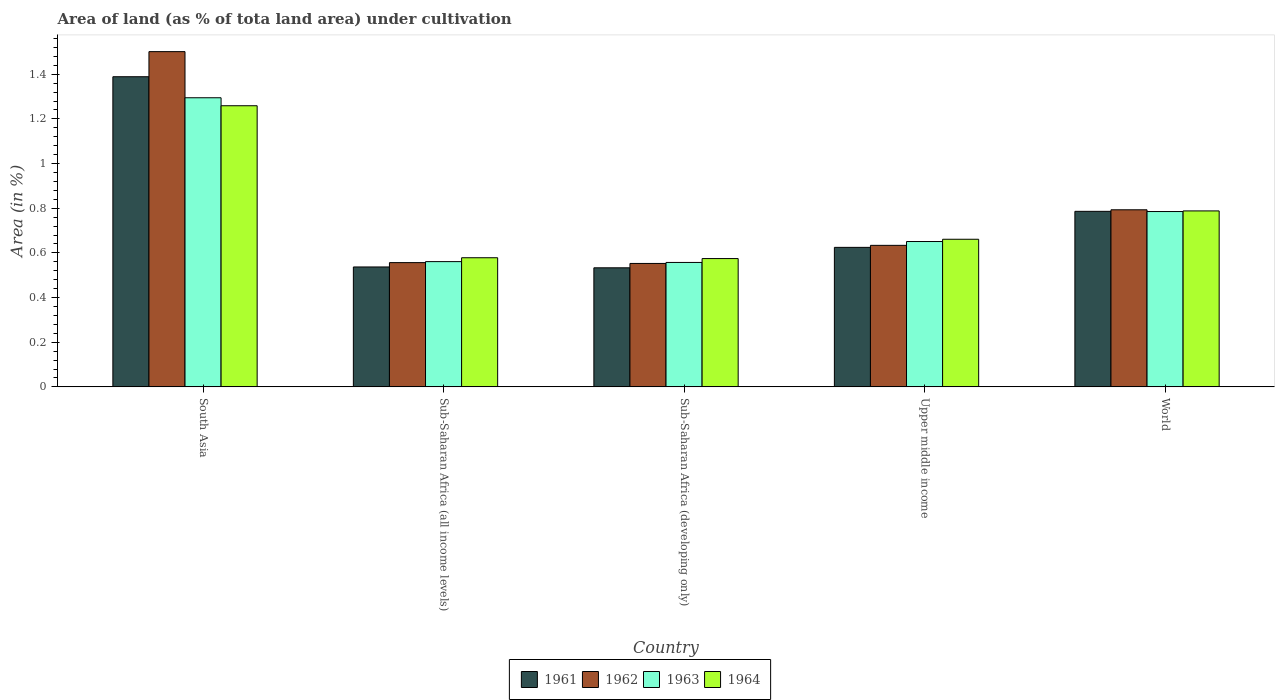How many different coloured bars are there?
Give a very brief answer. 4. Are the number of bars on each tick of the X-axis equal?
Keep it short and to the point. Yes. How many bars are there on the 1st tick from the right?
Your response must be concise. 4. What is the label of the 2nd group of bars from the left?
Make the answer very short. Sub-Saharan Africa (all income levels). What is the percentage of land under cultivation in 1964 in South Asia?
Provide a succinct answer. 1.26. Across all countries, what is the maximum percentage of land under cultivation in 1961?
Give a very brief answer. 1.39. Across all countries, what is the minimum percentage of land under cultivation in 1964?
Provide a succinct answer. 0.57. In which country was the percentage of land under cultivation in 1961 minimum?
Provide a short and direct response. Sub-Saharan Africa (developing only). What is the total percentage of land under cultivation in 1962 in the graph?
Provide a succinct answer. 4.04. What is the difference between the percentage of land under cultivation in 1964 in Sub-Saharan Africa (all income levels) and that in Sub-Saharan Africa (developing only)?
Provide a short and direct response. 0. What is the difference between the percentage of land under cultivation in 1964 in Sub-Saharan Africa (developing only) and the percentage of land under cultivation in 1961 in Sub-Saharan Africa (all income levels)?
Your response must be concise. 0.04. What is the average percentage of land under cultivation in 1962 per country?
Your response must be concise. 0.81. What is the difference between the percentage of land under cultivation of/in 1961 and percentage of land under cultivation of/in 1963 in Sub-Saharan Africa (developing only)?
Your response must be concise. -0.02. What is the ratio of the percentage of land under cultivation in 1964 in Sub-Saharan Africa (all income levels) to that in Sub-Saharan Africa (developing only)?
Offer a very short reply. 1.01. Is the difference between the percentage of land under cultivation in 1961 in Sub-Saharan Africa (developing only) and World greater than the difference between the percentage of land under cultivation in 1963 in Sub-Saharan Africa (developing only) and World?
Keep it short and to the point. No. What is the difference between the highest and the second highest percentage of land under cultivation in 1962?
Your response must be concise. -0.71. What is the difference between the highest and the lowest percentage of land under cultivation in 1963?
Offer a very short reply. 0.74. In how many countries, is the percentage of land under cultivation in 1964 greater than the average percentage of land under cultivation in 1964 taken over all countries?
Provide a short and direct response. 2. Is the sum of the percentage of land under cultivation in 1963 in Sub-Saharan Africa (all income levels) and Upper middle income greater than the maximum percentage of land under cultivation in 1962 across all countries?
Provide a short and direct response. No. Is it the case that in every country, the sum of the percentage of land under cultivation in 1963 and percentage of land under cultivation in 1961 is greater than the sum of percentage of land under cultivation in 1962 and percentage of land under cultivation in 1964?
Keep it short and to the point. No. What does the 4th bar from the left in Sub-Saharan Africa (developing only) represents?
Provide a short and direct response. 1964. What does the 1st bar from the right in Upper middle income represents?
Your answer should be very brief. 1964. Is it the case that in every country, the sum of the percentage of land under cultivation in 1964 and percentage of land under cultivation in 1963 is greater than the percentage of land under cultivation in 1961?
Offer a very short reply. Yes. Are all the bars in the graph horizontal?
Provide a succinct answer. No. How many countries are there in the graph?
Your response must be concise. 5. What is the difference between two consecutive major ticks on the Y-axis?
Provide a succinct answer. 0.2. Are the values on the major ticks of Y-axis written in scientific E-notation?
Keep it short and to the point. No. Does the graph contain grids?
Your answer should be very brief. No. Where does the legend appear in the graph?
Ensure brevity in your answer.  Bottom center. How are the legend labels stacked?
Offer a terse response. Horizontal. What is the title of the graph?
Keep it short and to the point. Area of land (as % of tota land area) under cultivation. Does "2000" appear as one of the legend labels in the graph?
Keep it short and to the point. No. What is the label or title of the X-axis?
Offer a very short reply. Country. What is the label or title of the Y-axis?
Ensure brevity in your answer.  Area (in %). What is the Area (in %) of 1961 in South Asia?
Give a very brief answer. 1.39. What is the Area (in %) of 1962 in South Asia?
Your response must be concise. 1.5. What is the Area (in %) of 1963 in South Asia?
Offer a terse response. 1.29. What is the Area (in %) of 1964 in South Asia?
Ensure brevity in your answer.  1.26. What is the Area (in %) in 1961 in Sub-Saharan Africa (all income levels)?
Make the answer very short. 0.54. What is the Area (in %) in 1962 in Sub-Saharan Africa (all income levels)?
Keep it short and to the point. 0.56. What is the Area (in %) in 1963 in Sub-Saharan Africa (all income levels)?
Provide a succinct answer. 0.56. What is the Area (in %) in 1964 in Sub-Saharan Africa (all income levels)?
Offer a terse response. 0.58. What is the Area (in %) in 1961 in Sub-Saharan Africa (developing only)?
Keep it short and to the point. 0.53. What is the Area (in %) of 1962 in Sub-Saharan Africa (developing only)?
Ensure brevity in your answer.  0.55. What is the Area (in %) of 1963 in Sub-Saharan Africa (developing only)?
Provide a short and direct response. 0.56. What is the Area (in %) in 1964 in Sub-Saharan Africa (developing only)?
Provide a succinct answer. 0.57. What is the Area (in %) in 1961 in Upper middle income?
Provide a succinct answer. 0.62. What is the Area (in %) of 1962 in Upper middle income?
Make the answer very short. 0.63. What is the Area (in %) of 1963 in Upper middle income?
Your response must be concise. 0.65. What is the Area (in %) in 1964 in Upper middle income?
Ensure brevity in your answer.  0.66. What is the Area (in %) in 1961 in World?
Offer a very short reply. 0.79. What is the Area (in %) of 1962 in World?
Your answer should be compact. 0.79. What is the Area (in %) of 1963 in World?
Your response must be concise. 0.79. What is the Area (in %) of 1964 in World?
Your answer should be compact. 0.79. Across all countries, what is the maximum Area (in %) of 1961?
Your answer should be very brief. 1.39. Across all countries, what is the maximum Area (in %) in 1962?
Your response must be concise. 1.5. Across all countries, what is the maximum Area (in %) in 1963?
Provide a succinct answer. 1.29. Across all countries, what is the maximum Area (in %) in 1964?
Offer a terse response. 1.26. Across all countries, what is the minimum Area (in %) of 1961?
Your answer should be very brief. 0.53. Across all countries, what is the minimum Area (in %) in 1962?
Keep it short and to the point. 0.55. Across all countries, what is the minimum Area (in %) of 1963?
Provide a short and direct response. 0.56. Across all countries, what is the minimum Area (in %) of 1964?
Keep it short and to the point. 0.57. What is the total Area (in %) in 1961 in the graph?
Provide a succinct answer. 3.87. What is the total Area (in %) of 1962 in the graph?
Make the answer very short. 4.04. What is the total Area (in %) of 1963 in the graph?
Provide a short and direct response. 3.85. What is the total Area (in %) of 1964 in the graph?
Offer a very short reply. 3.86. What is the difference between the Area (in %) in 1961 in South Asia and that in Sub-Saharan Africa (all income levels)?
Give a very brief answer. 0.85. What is the difference between the Area (in %) in 1962 in South Asia and that in Sub-Saharan Africa (all income levels)?
Keep it short and to the point. 0.94. What is the difference between the Area (in %) of 1963 in South Asia and that in Sub-Saharan Africa (all income levels)?
Ensure brevity in your answer.  0.73. What is the difference between the Area (in %) of 1964 in South Asia and that in Sub-Saharan Africa (all income levels)?
Offer a very short reply. 0.68. What is the difference between the Area (in %) in 1961 in South Asia and that in Sub-Saharan Africa (developing only)?
Ensure brevity in your answer.  0.86. What is the difference between the Area (in %) in 1962 in South Asia and that in Sub-Saharan Africa (developing only)?
Give a very brief answer. 0.95. What is the difference between the Area (in %) of 1963 in South Asia and that in Sub-Saharan Africa (developing only)?
Offer a very short reply. 0.74. What is the difference between the Area (in %) of 1964 in South Asia and that in Sub-Saharan Africa (developing only)?
Provide a succinct answer. 0.68. What is the difference between the Area (in %) of 1961 in South Asia and that in Upper middle income?
Make the answer very short. 0.76. What is the difference between the Area (in %) in 1962 in South Asia and that in Upper middle income?
Make the answer very short. 0.87. What is the difference between the Area (in %) of 1963 in South Asia and that in Upper middle income?
Make the answer very short. 0.64. What is the difference between the Area (in %) of 1964 in South Asia and that in Upper middle income?
Offer a terse response. 0.6. What is the difference between the Area (in %) in 1961 in South Asia and that in World?
Provide a succinct answer. 0.6. What is the difference between the Area (in %) in 1962 in South Asia and that in World?
Ensure brevity in your answer.  0.71. What is the difference between the Area (in %) in 1963 in South Asia and that in World?
Offer a terse response. 0.51. What is the difference between the Area (in %) in 1964 in South Asia and that in World?
Offer a very short reply. 0.47. What is the difference between the Area (in %) in 1961 in Sub-Saharan Africa (all income levels) and that in Sub-Saharan Africa (developing only)?
Make the answer very short. 0. What is the difference between the Area (in %) in 1962 in Sub-Saharan Africa (all income levels) and that in Sub-Saharan Africa (developing only)?
Make the answer very short. 0. What is the difference between the Area (in %) in 1963 in Sub-Saharan Africa (all income levels) and that in Sub-Saharan Africa (developing only)?
Your response must be concise. 0. What is the difference between the Area (in %) of 1964 in Sub-Saharan Africa (all income levels) and that in Sub-Saharan Africa (developing only)?
Provide a short and direct response. 0. What is the difference between the Area (in %) of 1961 in Sub-Saharan Africa (all income levels) and that in Upper middle income?
Ensure brevity in your answer.  -0.09. What is the difference between the Area (in %) of 1962 in Sub-Saharan Africa (all income levels) and that in Upper middle income?
Provide a short and direct response. -0.08. What is the difference between the Area (in %) of 1963 in Sub-Saharan Africa (all income levels) and that in Upper middle income?
Offer a terse response. -0.09. What is the difference between the Area (in %) of 1964 in Sub-Saharan Africa (all income levels) and that in Upper middle income?
Make the answer very short. -0.08. What is the difference between the Area (in %) in 1961 in Sub-Saharan Africa (all income levels) and that in World?
Your answer should be compact. -0.25. What is the difference between the Area (in %) of 1962 in Sub-Saharan Africa (all income levels) and that in World?
Ensure brevity in your answer.  -0.24. What is the difference between the Area (in %) of 1963 in Sub-Saharan Africa (all income levels) and that in World?
Provide a short and direct response. -0.22. What is the difference between the Area (in %) in 1964 in Sub-Saharan Africa (all income levels) and that in World?
Provide a succinct answer. -0.21. What is the difference between the Area (in %) in 1961 in Sub-Saharan Africa (developing only) and that in Upper middle income?
Offer a very short reply. -0.09. What is the difference between the Area (in %) of 1962 in Sub-Saharan Africa (developing only) and that in Upper middle income?
Provide a succinct answer. -0.08. What is the difference between the Area (in %) of 1963 in Sub-Saharan Africa (developing only) and that in Upper middle income?
Offer a very short reply. -0.09. What is the difference between the Area (in %) in 1964 in Sub-Saharan Africa (developing only) and that in Upper middle income?
Make the answer very short. -0.09. What is the difference between the Area (in %) in 1961 in Sub-Saharan Africa (developing only) and that in World?
Your answer should be compact. -0.25. What is the difference between the Area (in %) of 1962 in Sub-Saharan Africa (developing only) and that in World?
Offer a very short reply. -0.24. What is the difference between the Area (in %) of 1963 in Sub-Saharan Africa (developing only) and that in World?
Your answer should be very brief. -0.23. What is the difference between the Area (in %) in 1964 in Sub-Saharan Africa (developing only) and that in World?
Your response must be concise. -0.21. What is the difference between the Area (in %) in 1961 in Upper middle income and that in World?
Offer a very short reply. -0.16. What is the difference between the Area (in %) of 1962 in Upper middle income and that in World?
Keep it short and to the point. -0.16. What is the difference between the Area (in %) in 1963 in Upper middle income and that in World?
Ensure brevity in your answer.  -0.13. What is the difference between the Area (in %) in 1964 in Upper middle income and that in World?
Give a very brief answer. -0.13. What is the difference between the Area (in %) of 1961 in South Asia and the Area (in %) of 1962 in Sub-Saharan Africa (all income levels)?
Your answer should be compact. 0.83. What is the difference between the Area (in %) of 1961 in South Asia and the Area (in %) of 1963 in Sub-Saharan Africa (all income levels)?
Your answer should be compact. 0.83. What is the difference between the Area (in %) of 1961 in South Asia and the Area (in %) of 1964 in Sub-Saharan Africa (all income levels)?
Your response must be concise. 0.81. What is the difference between the Area (in %) of 1962 in South Asia and the Area (in %) of 1963 in Sub-Saharan Africa (all income levels)?
Your answer should be very brief. 0.94. What is the difference between the Area (in %) in 1962 in South Asia and the Area (in %) in 1964 in Sub-Saharan Africa (all income levels)?
Your response must be concise. 0.92. What is the difference between the Area (in %) in 1963 in South Asia and the Area (in %) in 1964 in Sub-Saharan Africa (all income levels)?
Your answer should be very brief. 0.72. What is the difference between the Area (in %) in 1961 in South Asia and the Area (in %) in 1962 in Sub-Saharan Africa (developing only)?
Offer a very short reply. 0.84. What is the difference between the Area (in %) of 1961 in South Asia and the Area (in %) of 1963 in Sub-Saharan Africa (developing only)?
Your answer should be compact. 0.83. What is the difference between the Area (in %) in 1961 in South Asia and the Area (in %) in 1964 in Sub-Saharan Africa (developing only)?
Provide a succinct answer. 0.81. What is the difference between the Area (in %) in 1962 in South Asia and the Area (in %) in 1963 in Sub-Saharan Africa (developing only)?
Give a very brief answer. 0.94. What is the difference between the Area (in %) in 1962 in South Asia and the Area (in %) in 1964 in Sub-Saharan Africa (developing only)?
Your answer should be very brief. 0.93. What is the difference between the Area (in %) of 1963 in South Asia and the Area (in %) of 1964 in Sub-Saharan Africa (developing only)?
Your answer should be very brief. 0.72. What is the difference between the Area (in %) of 1961 in South Asia and the Area (in %) of 1962 in Upper middle income?
Your answer should be very brief. 0.76. What is the difference between the Area (in %) of 1961 in South Asia and the Area (in %) of 1963 in Upper middle income?
Keep it short and to the point. 0.74. What is the difference between the Area (in %) in 1961 in South Asia and the Area (in %) in 1964 in Upper middle income?
Provide a succinct answer. 0.73. What is the difference between the Area (in %) in 1962 in South Asia and the Area (in %) in 1963 in Upper middle income?
Ensure brevity in your answer.  0.85. What is the difference between the Area (in %) in 1962 in South Asia and the Area (in %) in 1964 in Upper middle income?
Your answer should be very brief. 0.84. What is the difference between the Area (in %) of 1963 in South Asia and the Area (in %) of 1964 in Upper middle income?
Your response must be concise. 0.63. What is the difference between the Area (in %) in 1961 in South Asia and the Area (in %) in 1962 in World?
Your response must be concise. 0.6. What is the difference between the Area (in %) in 1961 in South Asia and the Area (in %) in 1963 in World?
Keep it short and to the point. 0.6. What is the difference between the Area (in %) in 1961 in South Asia and the Area (in %) in 1964 in World?
Your answer should be compact. 0.6. What is the difference between the Area (in %) of 1962 in South Asia and the Area (in %) of 1963 in World?
Offer a terse response. 0.72. What is the difference between the Area (in %) in 1962 in South Asia and the Area (in %) in 1964 in World?
Make the answer very short. 0.71. What is the difference between the Area (in %) in 1963 in South Asia and the Area (in %) in 1964 in World?
Offer a terse response. 0.51. What is the difference between the Area (in %) of 1961 in Sub-Saharan Africa (all income levels) and the Area (in %) of 1962 in Sub-Saharan Africa (developing only)?
Your response must be concise. -0.02. What is the difference between the Area (in %) of 1961 in Sub-Saharan Africa (all income levels) and the Area (in %) of 1963 in Sub-Saharan Africa (developing only)?
Your answer should be compact. -0.02. What is the difference between the Area (in %) of 1961 in Sub-Saharan Africa (all income levels) and the Area (in %) of 1964 in Sub-Saharan Africa (developing only)?
Your answer should be compact. -0.04. What is the difference between the Area (in %) in 1962 in Sub-Saharan Africa (all income levels) and the Area (in %) in 1963 in Sub-Saharan Africa (developing only)?
Give a very brief answer. -0. What is the difference between the Area (in %) in 1962 in Sub-Saharan Africa (all income levels) and the Area (in %) in 1964 in Sub-Saharan Africa (developing only)?
Provide a short and direct response. -0.02. What is the difference between the Area (in %) of 1963 in Sub-Saharan Africa (all income levels) and the Area (in %) of 1964 in Sub-Saharan Africa (developing only)?
Make the answer very short. -0.01. What is the difference between the Area (in %) of 1961 in Sub-Saharan Africa (all income levels) and the Area (in %) of 1962 in Upper middle income?
Give a very brief answer. -0.1. What is the difference between the Area (in %) of 1961 in Sub-Saharan Africa (all income levels) and the Area (in %) of 1963 in Upper middle income?
Your answer should be very brief. -0.11. What is the difference between the Area (in %) of 1961 in Sub-Saharan Africa (all income levels) and the Area (in %) of 1964 in Upper middle income?
Make the answer very short. -0.12. What is the difference between the Area (in %) of 1962 in Sub-Saharan Africa (all income levels) and the Area (in %) of 1963 in Upper middle income?
Keep it short and to the point. -0.09. What is the difference between the Area (in %) in 1962 in Sub-Saharan Africa (all income levels) and the Area (in %) in 1964 in Upper middle income?
Ensure brevity in your answer.  -0.1. What is the difference between the Area (in %) in 1963 in Sub-Saharan Africa (all income levels) and the Area (in %) in 1964 in Upper middle income?
Make the answer very short. -0.1. What is the difference between the Area (in %) of 1961 in Sub-Saharan Africa (all income levels) and the Area (in %) of 1962 in World?
Your answer should be very brief. -0.26. What is the difference between the Area (in %) of 1961 in Sub-Saharan Africa (all income levels) and the Area (in %) of 1963 in World?
Keep it short and to the point. -0.25. What is the difference between the Area (in %) in 1961 in Sub-Saharan Africa (all income levels) and the Area (in %) in 1964 in World?
Your answer should be very brief. -0.25. What is the difference between the Area (in %) in 1962 in Sub-Saharan Africa (all income levels) and the Area (in %) in 1963 in World?
Give a very brief answer. -0.23. What is the difference between the Area (in %) in 1962 in Sub-Saharan Africa (all income levels) and the Area (in %) in 1964 in World?
Ensure brevity in your answer.  -0.23. What is the difference between the Area (in %) in 1963 in Sub-Saharan Africa (all income levels) and the Area (in %) in 1964 in World?
Offer a very short reply. -0.23. What is the difference between the Area (in %) of 1961 in Sub-Saharan Africa (developing only) and the Area (in %) of 1962 in Upper middle income?
Your answer should be compact. -0.1. What is the difference between the Area (in %) in 1961 in Sub-Saharan Africa (developing only) and the Area (in %) in 1963 in Upper middle income?
Your answer should be very brief. -0.12. What is the difference between the Area (in %) in 1961 in Sub-Saharan Africa (developing only) and the Area (in %) in 1964 in Upper middle income?
Your response must be concise. -0.13. What is the difference between the Area (in %) of 1962 in Sub-Saharan Africa (developing only) and the Area (in %) of 1963 in Upper middle income?
Keep it short and to the point. -0.1. What is the difference between the Area (in %) of 1962 in Sub-Saharan Africa (developing only) and the Area (in %) of 1964 in Upper middle income?
Keep it short and to the point. -0.11. What is the difference between the Area (in %) in 1963 in Sub-Saharan Africa (developing only) and the Area (in %) in 1964 in Upper middle income?
Make the answer very short. -0.1. What is the difference between the Area (in %) of 1961 in Sub-Saharan Africa (developing only) and the Area (in %) of 1962 in World?
Offer a terse response. -0.26. What is the difference between the Area (in %) of 1961 in Sub-Saharan Africa (developing only) and the Area (in %) of 1963 in World?
Make the answer very short. -0.25. What is the difference between the Area (in %) in 1961 in Sub-Saharan Africa (developing only) and the Area (in %) in 1964 in World?
Provide a succinct answer. -0.25. What is the difference between the Area (in %) in 1962 in Sub-Saharan Africa (developing only) and the Area (in %) in 1963 in World?
Offer a very short reply. -0.23. What is the difference between the Area (in %) of 1962 in Sub-Saharan Africa (developing only) and the Area (in %) of 1964 in World?
Offer a very short reply. -0.24. What is the difference between the Area (in %) in 1963 in Sub-Saharan Africa (developing only) and the Area (in %) in 1964 in World?
Give a very brief answer. -0.23. What is the difference between the Area (in %) of 1961 in Upper middle income and the Area (in %) of 1962 in World?
Keep it short and to the point. -0.17. What is the difference between the Area (in %) in 1961 in Upper middle income and the Area (in %) in 1963 in World?
Provide a succinct answer. -0.16. What is the difference between the Area (in %) in 1961 in Upper middle income and the Area (in %) in 1964 in World?
Provide a succinct answer. -0.16. What is the difference between the Area (in %) in 1962 in Upper middle income and the Area (in %) in 1963 in World?
Your response must be concise. -0.15. What is the difference between the Area (in %) of 1962 in Upper middle income and the Area (in %) of 1964 in World?
Your answer should be very brief. -0.15. What is the difference between the Area (in %) in 1963 in Upper middle income and the Area (in %) in 1964 in World?
Make the answer very short. -0.14. What is the average Area (in %) of 1961 per country?
Offer a terse response. 0.77. What is the average Area (in %) of 1962 per country?
Ensure brevity in your answer.  0.81. What is the average Area (in %) of 1963 per country?
Offer a terse response. 0.77. What is the average Area (in %) of 1964 per country?
Provide a succinct answer. 0.77. What is the difference between the Area (in %) of 1961 and Area (in %) of 1962 in South Asia?
Offer a very short reply. -0.11. What is the difference between the Area (in %) in 1961 and Area (in %) in 1963 in South Asia?
Your response must be concise. 0.09. What is the difference between the Area (in %) of 1961 and Area (in %) of 1964 in South Asia?
Offer a very short reply. 0.13. What is the difference between the Area (in %) of 1962 and Area (in %) of 1963 in South Asia?
Make the answer very short. 0.21. What is the difference between the Area (in %) of 1962 and Area (in %) of 1964 in South Asia?
Your answer should be very brief. 0.24. What is the difference between the Area (in %) of 1963 and Area (in %) of 1964 in South Asia?
Your response must be concise. 0.04. What is the difference between the Area (in %) of 1961 and Area (in %) of 1962 in Sub-Saharan Africa (all income levels)?
Ensure brevity in your answer.  -0.02. What is the difference between the Area (in %) of 1961 and Area (in %) of 1963 in Sub-Saharan Africa (all income levels)?
Offer a terse response. -0.02. What is the difference between the Area (in %) in 1961 and Area (in %) in 1964 in Sub-Saharan Africa (all income levels)?
Give a very brief answer. -0.04. What is the difference between the Area (in %) of 1962 and Area (in %) of 1963 in Sub-Saharan Africa (all income levels)?
Keep it short and to the point. -0. What is the difference between the Area (in %) of 1962 and Area (in %) of 1964 in Sub-Saharan Africa (all income levels)?
Offer a very short reply. -0.02. What is the difference between the Area (in %) of 1963 and Area (in %) of 1964 in Sub-Saharan Africa (all income levels)?
Offer a very short reply. -0.02. What is the difference between the Area (in %) of 1961 and Area (in %) of 1962 in Sub-Saharan Africa (developing only)?
Keep it short and to the point. -0.02. What is the difference between the Area (in %) in 1961 and Area (in %) in 1963 in Sub-Saharan Africa (developing only)?
Your answer should be compact. -0.02. What is the difference between the Area (in %) of 1961 and Area (in %) of 1964 in Sub-Saharan Africa (developing only)?
Your response must be concise. -0.04. What is the difference between the Area (in %) of 1962 and Area (in %) of 1963 in Sub-Saharan Africa (developing only)?
Your answer should be compact. -0. What is the difference between the Area (in %) in 1962 and Area (in %) in 1964 in Sub-Saharan Africa (developing only)?
Ensure brevity in your answer.  -0.02. What is the difference between the Area (in %) of 1963 and Area (in %) of 1964 in Sub-Saharan Africa (developing only)?
Your answer should be compact. -0.02. What is the difference between the Area (in %) of 1961 and Area (in %) of 1962 in Upper middle income?
Offer a very short reply. -0.01. What is the difference between the Area (in %) of 1961 and Area (in %) of 1963 in Upper middle income?
Offer a terse response. -0.03. What is the difference between the Area (in %) in 1961 and Area (in %) in 1964 in Upper middle income?
Ensure brevity in your answer.  -0.04. What is the difference between the Area (in %) in 1962 and Area (in %) in 1963 in Upper middle income?
Offer a very short reply. -0.02. What is the difference between the Area (in %) in 1962 and Area (in %) in 1964 in Upper middle income?
Give a very brief answer. -0.03. What is the difference between the Area (in %) in 1963 and Area (in %) in 1964 in Upper middle income?
Keep it short and to the point. -0.01. What is the difference between the Area (in %) of 1961 and Area (in %) of 1962 in World?
Keep it short and to the point. -0.01. What is the difference between the Area (in %) of 1961 and Area (in %) of 1963 in World?
Provide a short and direct response. 0. What is the difference between the Area (in %) in 1961 and Area (in %) in 1964 in World?
Give a very brief answer. -0. What is the difference between the Area (in %) of 1962 and Area (in %) of 1963 in World?
Provide a succinct answer. 0.01. What is the difference between the Area (in %) in 1962 and Area (in %) in 1964 in World?
Provide a short and direct response. 0.01. What is the difference between the Area (in %) of 1963 and Area (in %) of 1964 in World?
Keep it short and to the point. -0. What is the ratio of the Area (in %) in 1961 in South Asia to that in Sub-Saharan Africa (all income levels)?
Your answer should be compact. 2.59. What is the ratio of the Area (in %) in 1962 in South Asia to that in Sub-Saharan Africa (all income levels)?
Provide a succinct answer. 2.7. What is the ratio of the Area (in %) of 1963 in South Asia to that in Sub-Saharan Africa (all income levels)?
Offer a terse response. 2.31. What is the ratio of the Area (in %) in 1964 in South Asia to that in Sub-Saharan Africa (all income levels)?
Keep it short and to the point. 2.18. What is the ratio of the Area (in %) of 1961 in South Asia to that in Sub-Saharan Africa (developing only)?
Offer a very short reply. 2.6. What is the ratio of the Area (in %) of 1962 in South Asia to that in Sub-Saharan Africa (developing only)?
Provide a succinct answer. 2.72. What is the ratio of the Area (in %) in 1963 in South Asia to that in Sub-Saharan Africa (developing only)?
Offer a terse response. 2.32. What is the ratio of the Area (in %) of 1964 in South Asia to that in Sub-Saharan Africa (developing only)?
Make the answer very short. 2.19. What is the ratio of the Area (in %) in 1961 in South Asia to that in Upper middle income?
Keep it short and to the point. 2.22. What is the ratio of the Area (in %) in 1962 in South Asia to that in Upper middle income?
Your answer should be very brief. 2.37. What is the ratio of the Area (in %) in 1963 in South Asia to that in Upper middle income?
Give a very brief answer. 1.99. What is the ratio of the Area (in %) in 1964 in South Asia to that in Upper middle income?
Keep it short and to the point. 1.9. What is the ratio of the Area (in %) of 1961 in South Asia to that in World?
Offer a terse response. 1.77. What is the ratio of the Area (in %) of 1962 in South Asia to that in World?
Your response must be concise. 1.89. What is the ratio of the Area (in %) in 1963 in South Asia to that in World?
Your response must be concise. 1.65. What is the ratio of the Area (in %) in 1964 in South Asia to that in World?
Offer a very short reply. 1.6. What is the ratio of the Area (in %) of 1961 in Sub-Saharan Africa (all income levels) to that in Sub-Saharan Africa (developing only)?
Give a very brief answer. 1.01. What is the ratio of the Area (in %) of 1962 in Sub-Saharan Africa (all income levels) to that in Sub-Saharan Africa (developing only)?
Give a very brief answer. 1.01. What is the ratio of the Area (in %) of 1963 in Sub-Saharan Africa (all income levels) to that in Sub-Saharan Africa (developing only)?
Keep it short and to the point. 1.01. What is the ratio of the Area (in %) in 1964 in Sub-Saharan Africa (all income levels) to that in Sub-Saharan Africa (developing only)?
Your response must be concise. 1.01. What is the ratio of the Area (in %) in 1961 in Sub-Saharan Africa (all income levels) to that in Upper middle income?
Give a very brief answer. 0.86. What is the ratio of the Area (in %) of 1962 in Sub-Saharan Africa (all income levels) to that in Upper middle income?
Provide a short and direct response. 0.88. What is the ratio of the Area (in %) of 1963 in Sub-Saharan Africa (all income levels) to that in Upper middle income?
Offer a very short reply. 0.86. What is the ratio of the Area (in %) of 1964 in Sub-Saharan Africa (all income levels) to that in Upper middle income?
Provide a short and direct response. 0.87. What is the ratio of the Area (in %) in 1961 in Sub-Saharan Africa (all income levels) to that in World?
Provide a succinct answer. 0.68. What is the ratio of the Area (in %) in 1962 in Sub-Saharan Africa (all income levels) to that in World?
Provide a short and direct response. 0.7. What is the ratio of the Area (in %) of 1963 in Sub-Saharan Africa (all income levels) to that in World?
Provide a short and direct response. 0.71. What is the ratio of the Area (in %) in 1964 in Sub-Saharan Africa (all income levels) to that in World?
Provide a short and direct response. 0.73. What is the ratio of the Area (in %) of 1961 in Sub-Saharan Africa (developing only) to that in Upper middle income?
Make the answer very short. 0.85. What is the ratio of the Area (in %) in 1962 in Sub-Saharan Africa (developing only) to that in Upper middle income?
Ensure brevity in your answer.  0.87. What is the ratio of the Area (in %) of 1963 in Sub-Saharan Africa (developing only) to that in Upper middle income?
Your answer should be compact. 0.86. What is the ratio of the Area (in %) of 1964 in Sub-Saharan Africa (developing only) to that in Upper middle income?
Provide a succinct answer. 0.87. What is the ratio of the Area (in %) of 1961 in Sub-Saharan Africa (developing only) to that in World?
Provide a short and direct response. 0.68. What is the ratio of the Area (in %) of 1962 in Sub-Saharan Africa (developing only) to that in World?
Make the answer very short. 0.7. What is the ratio of the Area (in %) of 1963 in Sub-Saharan Africa (developing only) to that in World?
Provide a succinct answer. 0.71. What is the ratio of the Area (in %) of 1964 in Sub-Saharan Africa (developing only) to that in World?
Keep it short and to the point. 0.73. What is the ratio of the Area (in %) of 1961 in Upper middle income to that in World?
Provide a short and direct response. 0.79. What is the ratio of the Area (in %) in 1962 in Upper middle income to that in World?
Your response must be concise. 0.8. What is the ratio of the Area (in %) in 1963 in Upper middle income to that in World?
Ensure brevity in your answer.  0.83. What is the ratio of the Area (in %) of 1964 in Upper middle income to that in World?
Keep it short and to the point. 0.84. What is the difference between the highest and the second highest Area (in %) in 1961?
Your answer should be very brief. 0.6. What is the difference between the highest and the second highest Area (in %) of 1962?
Ensure brevity in your answer.  0.71. What is the difference between the highest and the second highest Area (in %) in 1963?
Your response must be concise. 0.51. What is the difference between the highest and the second highest Area (in %) of 1964?
Offer a very short reply. 0.47. What is the difference between the highest and the lowest Area (in %) of 1961?
Your answer should be very brief. 0.86. What is the difference between the highest and the lowest Area (in %) in 1962?
Offer a terse response. 0.95. What is the difference between the highest and the lowest Area (in %) in 1963?
Offer a very short reply. 0.74. What is the difference between the highest and the lowest Area (in %) of 1964?
Your answer should be compact. 0.68. 